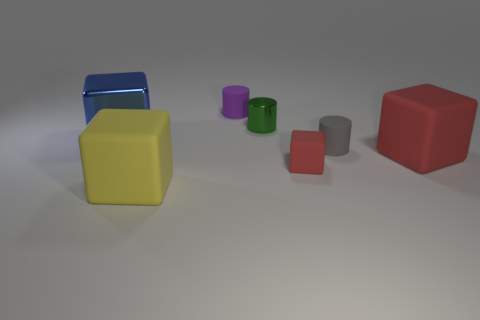How many large shiny objects are the same color as the shiny cylinder?
Make the answer very short. 0. What is the size of the purple cylinder that is made of the same material as the small red block?
Provide a succinct answer. Small. What size is the shiny thing that is behind the shiny thing that is to the left of the metal object that is to the right of the big blue metallic cube?
Give a very brief answer. Small. There is a cylinder that is to the right of the small red rubber object; what is its size?
Provide a succinct answer. Small. What number of purple objects are either matte blocks or cylinders?
Your answer should be compact. 1. Are there any blue blocks that have the same size as the gray rubber object?
Offer a very short reply. No. What material is the blue thing that is the same size as the yellow cube?
Your response must be concise. Metal. Does the blue thing behind the yellow object have the same size as the yellow cube in front of the big red rubber cube?
Your response must be concise. Yes. What number of objects are either gray cylinders or red cubes on the left side of the big red rubber object?
Make the answer very short. 2. Is there a blue object that has the same shape as the yellow rubber thing?
Provide a succinct answer. Yes. 